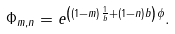Convert formula to latex. <formula><loc_0><loc_0><loc_500><loc_500>\Phi _ { m , n } = e ^ { \left ( ( 1 - m ) \frac { 1 } { b } + ( 1 - n ) b \right ) \phi } .</formula> 